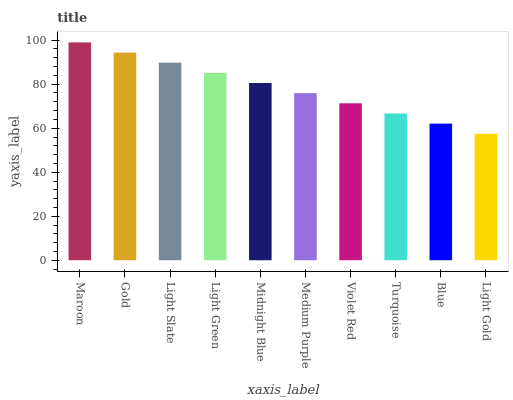Is Light Gold the minimum?
Answer yes or no. Yes. Is Maroon the maximum?
Answer yes or no. Yes. Is Gold the minimum?
Answer yes or no. No. Is Gold the maximum?
Answer yes or no. No. Is Maroon greater than Gold?
Answer yes or no. Yes. Is Gold less than Maroon?
Answer yes or no. Yes. Is Gold greater than Maroon?
Answer yes or no. No. Is Maroon less than Gold?
Answer yes or no. No. Is Midnight Blue the high median?
Answer yes or no. Yes. Is Medium Purple the low median?
Answer yes or no. Yes. Is Gold the high median?
Answer yes or no. No. Is Light Green the low median?
Answer yes or no. No. 